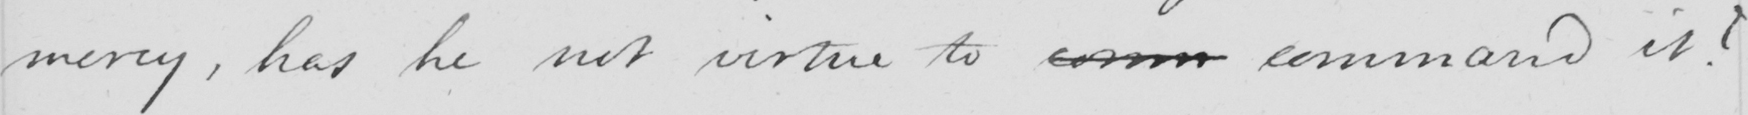What does this handwritten line say? mercy, has he not virtue to comm command it? 